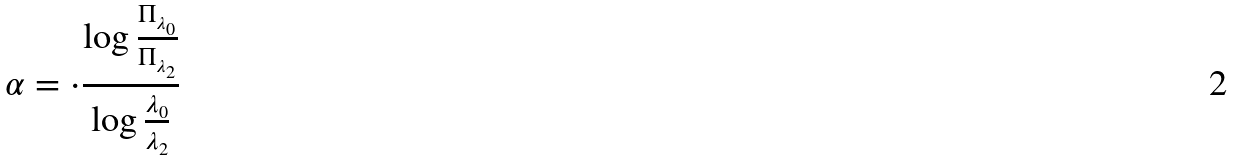<formula> <loc_0><loc_0><loc_500><loc_500>\alpha = \cdot \frac { \log \frac { \Pi _ { \lambda _ { 0 } } } { \Pi _ { \lambda _ { 2 } } } } { \log \frac { \lambda _ { 0 } } { \lambda _ { 2 } } }</formula> 